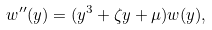Convert formula to latex. <formula><loc_0><loc_0><loc_500><loc_500>w ^ { \prime \prime } ( y ) = ( y ^ { 3 } + \zeta y + \mu ) w ( y ) ,</formula> 